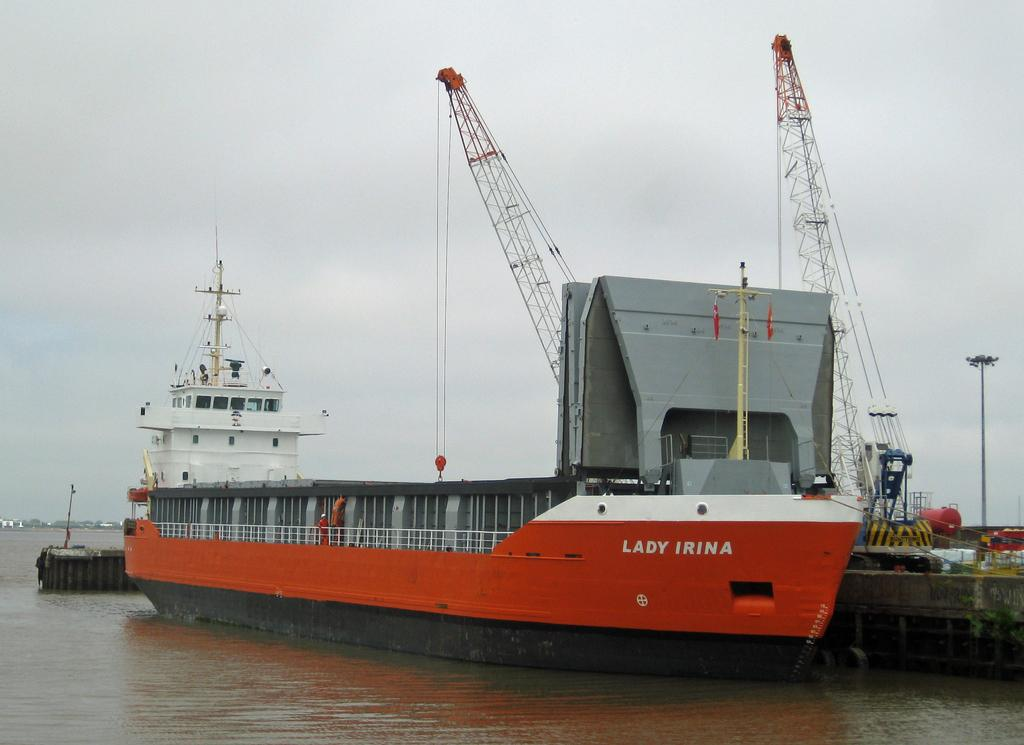<image>
Relay a brief, clear account of the picture shown. The name of the orange ship is Lady Irina. 